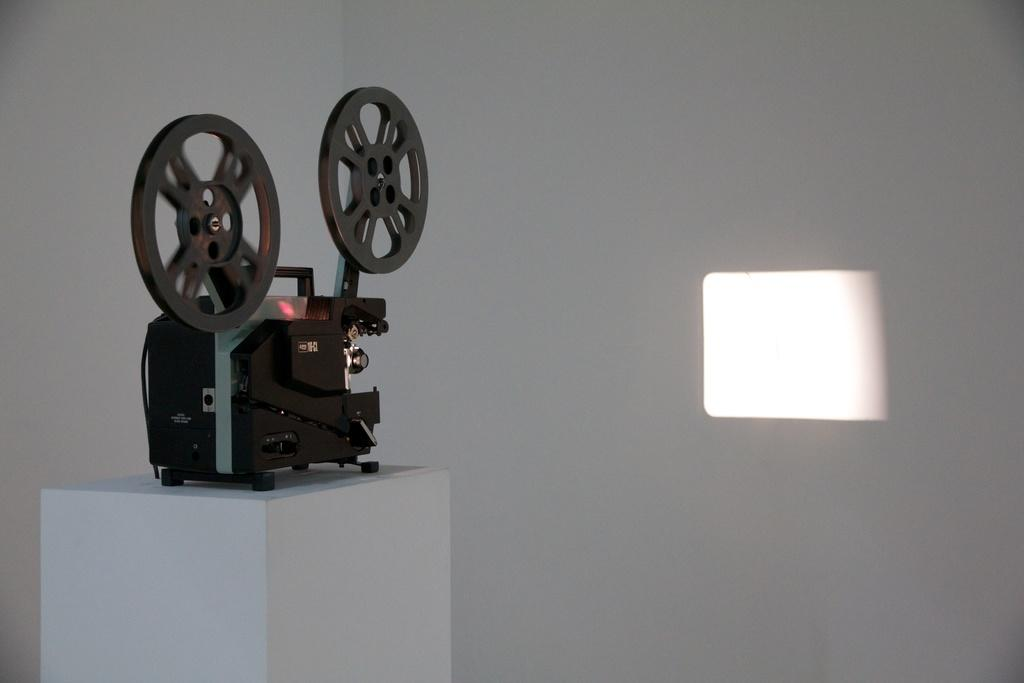What is the main object in the image? There is a rotor in the image. What is the rotor placed on? The rotor is placed on a wooden object. What type of behavior can be observed in the rotor in the image? The rotor is not exhibiting any behavior in the image, as it is a static object. 